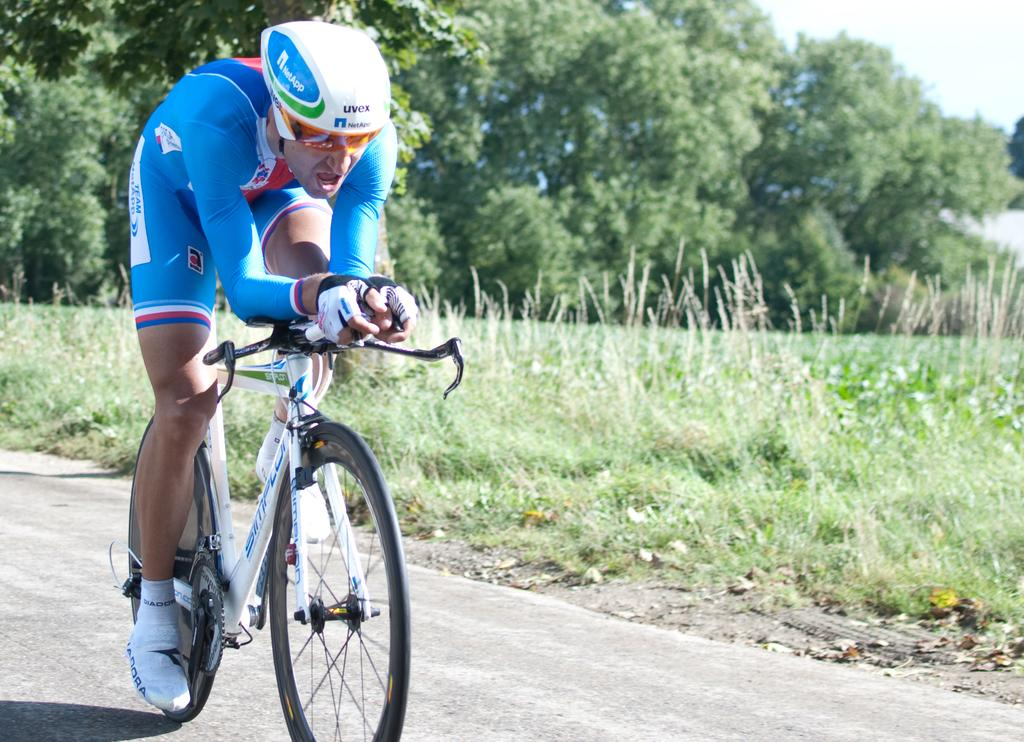What is the person in the image doing? The person is riding a bicycle in the image. Where is the person riding the bicycle? The person is on the road. What can be seen behind the person? There are trees behind the person. What type of vegetation is present in the image? There is grass and plants in the image. What part of the sky is visible in the image? The sky is visible in the top right corner of the image. What type of books can be seen in the library in the image? There is no library present in the image; it features a person riding a bicycle on the road with trees and grass in the background. What type of punishment is being administered to the person in the image? There is no punishment being administered in the image; the person is simply riding a bicycle. 